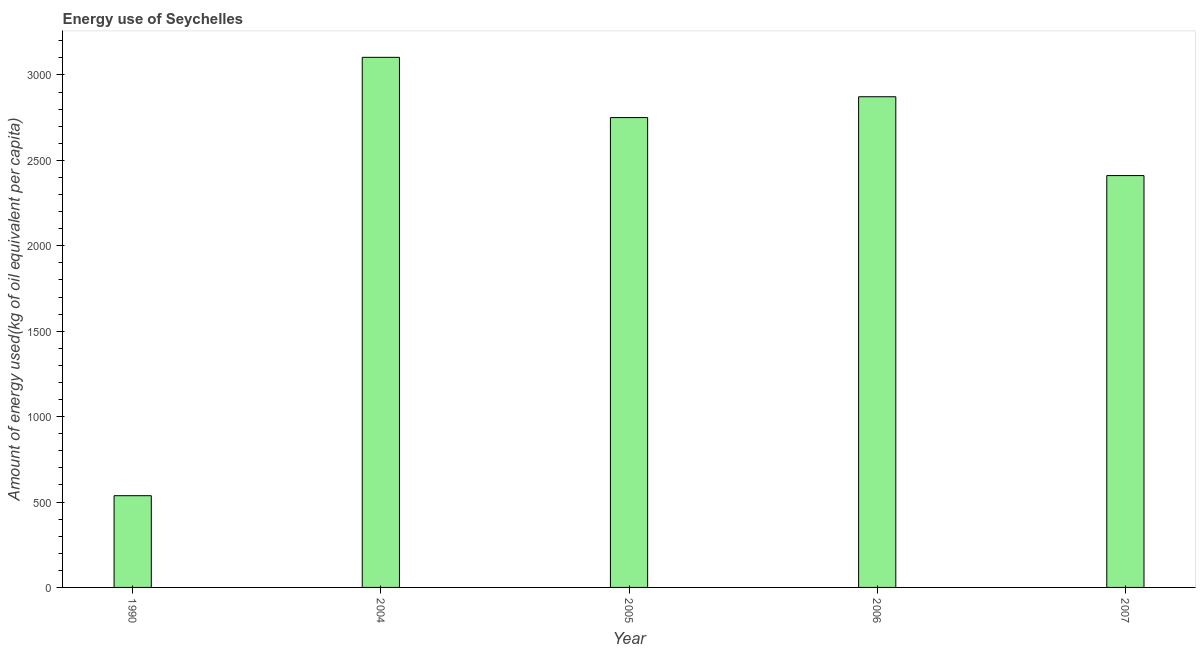Does the graph contain grids?
Make the answer very short. No. What is the title of the graph?
Your response must be concise. Energy use of Seychelles. What is the label or title of the Y-axis?
Offer a terse response. Amount of energy used(kg of oil equivalent per capita). What is the amount of energy used in 2004?
Provide a short and direct response. 3103.03. Across all years, what is the maximum amount of energy used?
Offer a very short reply. 3103.03. Across all years, what is the minimum amount of energy used?
Your response must be concise. 537. What is the sum of the amount of energy used?
Your answer should be compact. 1.17e+04. What is the difference between the amount of energy used in 2004 and 2005?
Keep it short and to the point. 352.73. What is the average amount of energy used per year?
Offer a very short reply. 2334.7. What is the median amount of energy used?
Keep it short and to the point. 2750.3. What is the ratio of the amount of energy used in 1990 to that in 2005?
Provide a succinct answer. 0.2. What is the difference between the highest and the second highest amount of energy used?
Your response must be concise. 230.69. Is the sum of the amount of energy used in 1990 and 2006 greater than the maximum amount of energy used across all years?
Your answer should be very brief. Yes. What is the difference between the highest and the lowest amount of energy used?
Ensure brevity in your answer.  2566.03. In how many years, is the amount of energy used greater than the average amount of energy used taken over all years?
Make the answer very short. 4. How many bars are there?
Keep it short and to the point. 5. Are all the bars in the graph horizontal?
Give a very brief answer. No. How many years are there in the graph?
Provide a succinct answer. 5. What is the difference between two consecutive major ticks on the Y-axis?
Keep it short and to the point. 500. Are the values on the major ticks of Y-axis written in scientific E-notation?
Make the answer very short. No. What is the Amount of energy used(kg of oil equivalent per capita) in 1990?
Offer a terse response. 537. What is the Amount of energy used(kg of oil equivalent per capita) in 2004?
Give a very brief answer. 3103.03. What is the Amount of energy used(kg of oil equivalent per capita) of 2005?
Ensure brevity in your answer.  2750.3. What is the Amount of energy used(kg of oil equivalent per capita) in 2006?
Your response must be concise. 2872.34. What is the Amount of energy used(kg of oil equivalent per capita) in 2007?
Keep it short and to the point. 2410.83. What is the difference between the Amount of energy used(kg of oil equivalent per capita) in 1990 and 2004?
Provide a short and direct response. -2566.03. What is the difference between the Amount of energy used(kg of oil equivalent per capita) in 1990 and 2005?
Your answer should be very brief. -2213.3. What is the difference between the Amount of energy used(kg of oil equivalent per capita) in 1990 and 2006?
Ensure brevity in your answer.  -2335.34. What is the difference between the Amount of energy used(kg of oil equivalent per capita) in 1990 and 2007?
Provide a short and direct response. -1873.83. What is the difference between the Amount of energy used(kg of oil equivalent per capita) in 2004 and 2005?
Provide a short and direct response. 352.73. What is the difference between the Amount of energy used(kg of oil equivalent per capita) in 2004 and 2006?
Give a very brief answer. 230.69. What is the difference between the Amount of energy used(kg of oil equivalent per capita) in 2004 and 2007?
Your answer should be compact. 692.2. What is the difference between the Amount of energy used(kg of oil equivalent per capita) in 2005 and 2006?
Offer a terse response. -122.04. What is the difference between the Amount of energy used(kg of oil equivalent per capita) in 2005 and 2007?
Make the answer very short. 339.47. What is the difference between the Amount of energy used(kg of oil equivalent per capita) in 2006 and 2007?
Your answer should be very brief. 461.51. What is the ratio of the Amount of energy used(kg of oil equivalent per capita) in 1990 to that in 2004?
Give a very brief answer. 0.17. What is the ratio of the Amount of energy used(kg of oil equivalent per capita) in 1990 to that in 2005?
Provide a short and direct response. 0.2. What is the ratio of the Amount of energy used(kg of oil equivalent per capita) in 1990 to that in 2006?
Your response must be concise. 0.19. What is the ratio of the Amount of energy used(kg of oil equivalent per capita) in 1990 to that in 2007?
Offer a very short reply. 0.22. What is the ratio of the Amount of energy used(kg of oil equivalent per capita) in 2004 to that in 2005?
Give a very brief answer. 1.13. What is the ratio of the Amount of energy used(kg of oil equivalent per capita) in 2004 to that in 2007?
Provide a succinct answer. 1.29. What is the ratio of the Amount of energy used(kg of oil equivalent per capita) in 2005 to that in 2006?
Make the answer very short. 0.96. What is the ratio of the Amount of energy used(kg of oil equivalent per capita) in 2005 to that in 2007?
Provide a short and direct response. 1.14. What is the ratio of the Amount of energy used(kg of oil equivalent per capita) in 2006 to that in 2007?
Your answer should be compact. 1.19. 